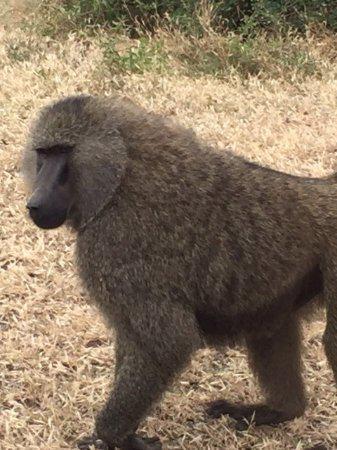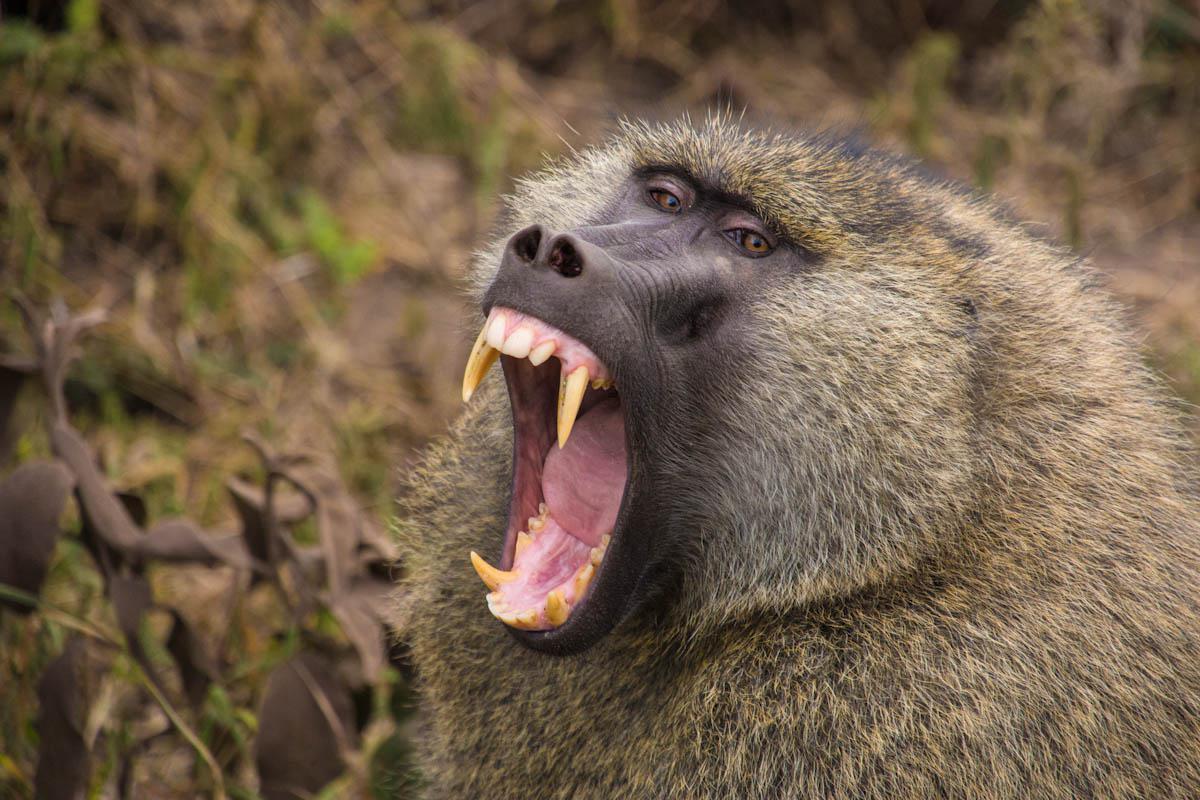The first image is the image on the left, the second image is the image on the right. Assess this claim about the two images: "An image shows two rear-facing baboons.". Correct or not? Answer yes or no. No. The first image is the image on the left, the second image is the image on the right. Assess this claim about the two images: "There are 2 adult apes in a grassy environment.". Correct or not? Answer yes or no. Yes. 